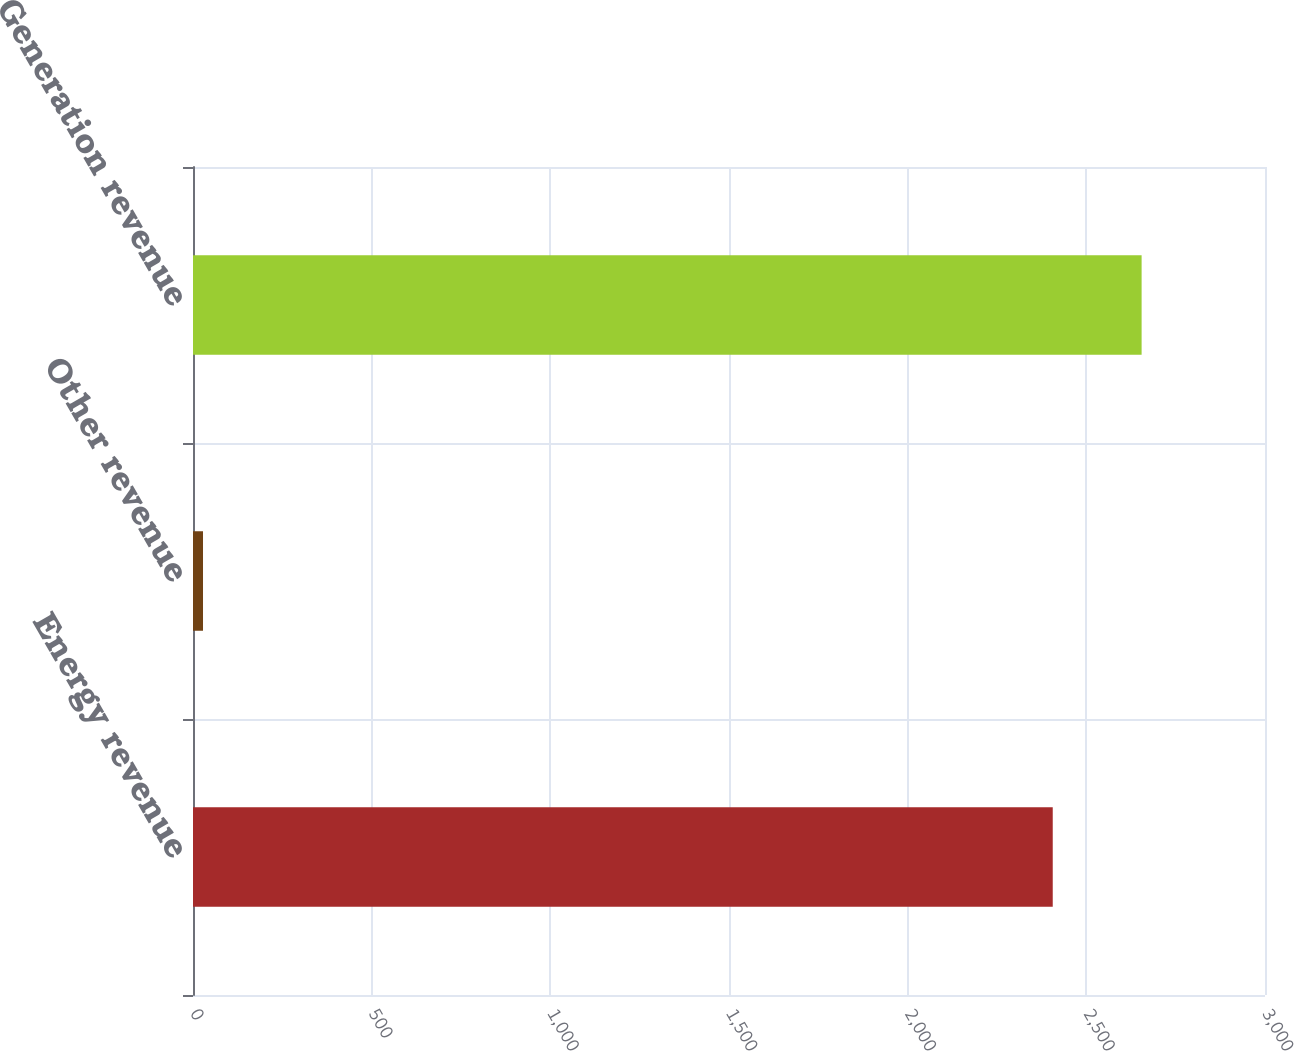Convert chart. <chart><loc_0><loc_0><loc_500><loc_500><bar_chart><fcel>Energy revenue<fcel>Other revenue<fcel>Generation revenue<nl><fcel>2406<fcel>28<fcel>2654.7<nl></chart> 